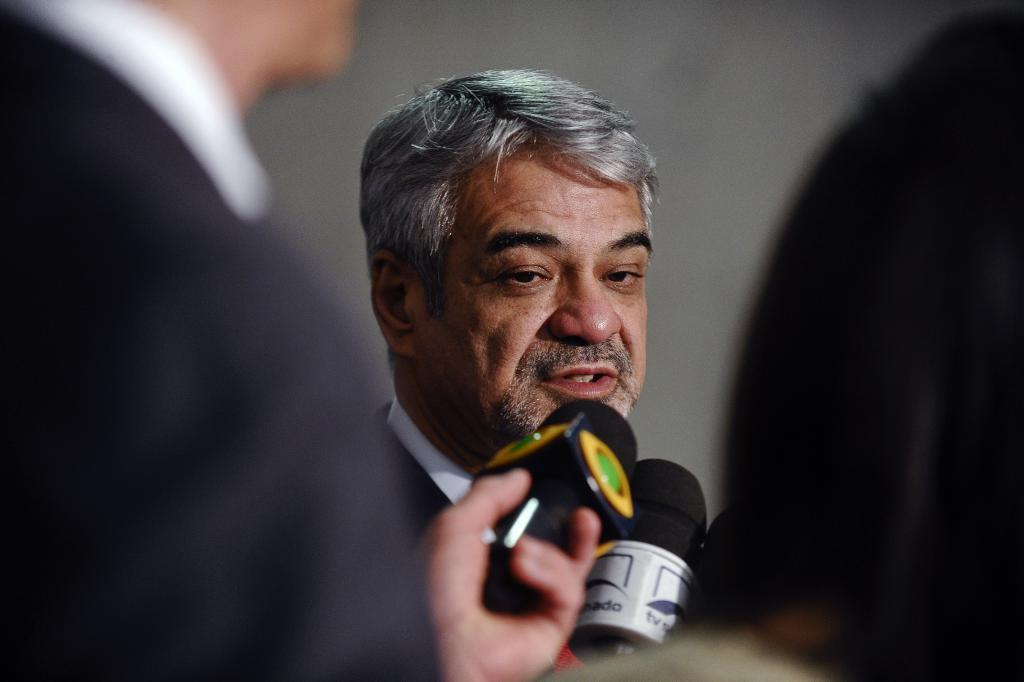How many people are present in the image? There are three people in the image. What objects are in front of the people? There are microphones in front of the people. Can you describe the background of the image? The background of the image is ash-colored. What type of nut is being cracked by the person in the middle of the image? There is no nut present in the image; the people are in front of microphones. 